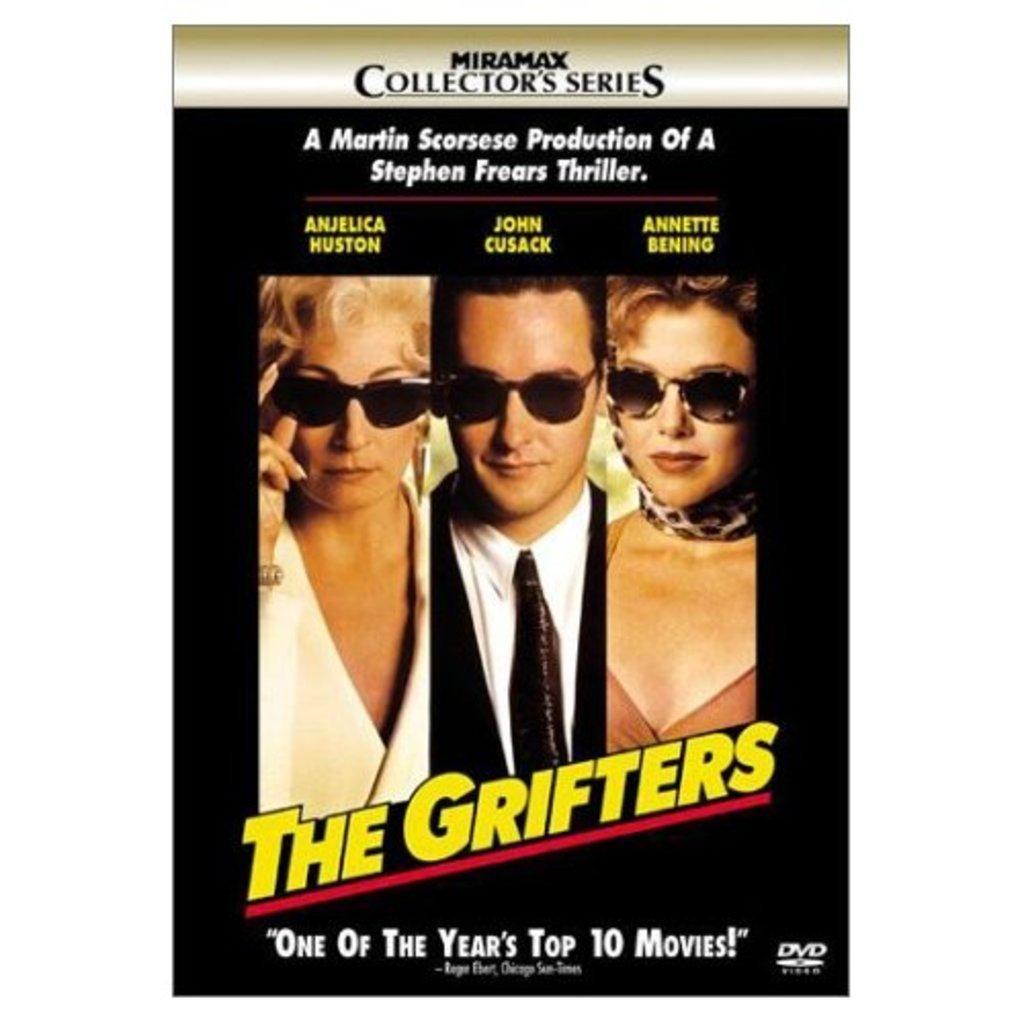Can you describe this image briefly? In this picture, there is a poster with pictures and text. In the poster, there are two women and a man. All of them are wearing goggles. 